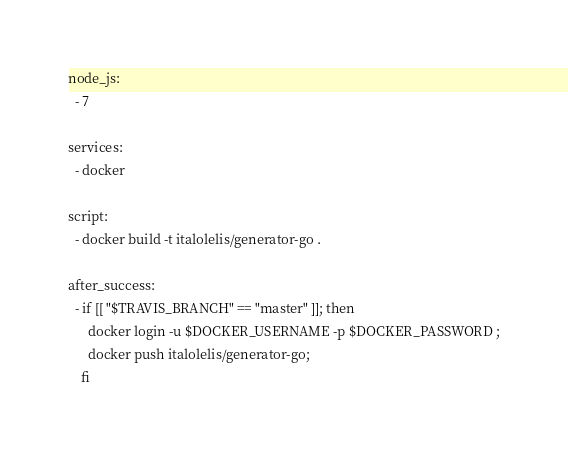Convert code to text. <code><loc_0><loc_0><loc_500><loc_500><_YAML_>node_js:
  - 7

services:
  - docker

script:
  - docker build -t italolelis/generator-go .

after_success:
  - if [[ "$TRAVIS_BRANCH" == "master" ]]; then
      docker login -u $DOCKER_USERNAME -p $DOCKER_PASSWORD ;
      docker push italolelis/generator-go;
    fi
</code> 